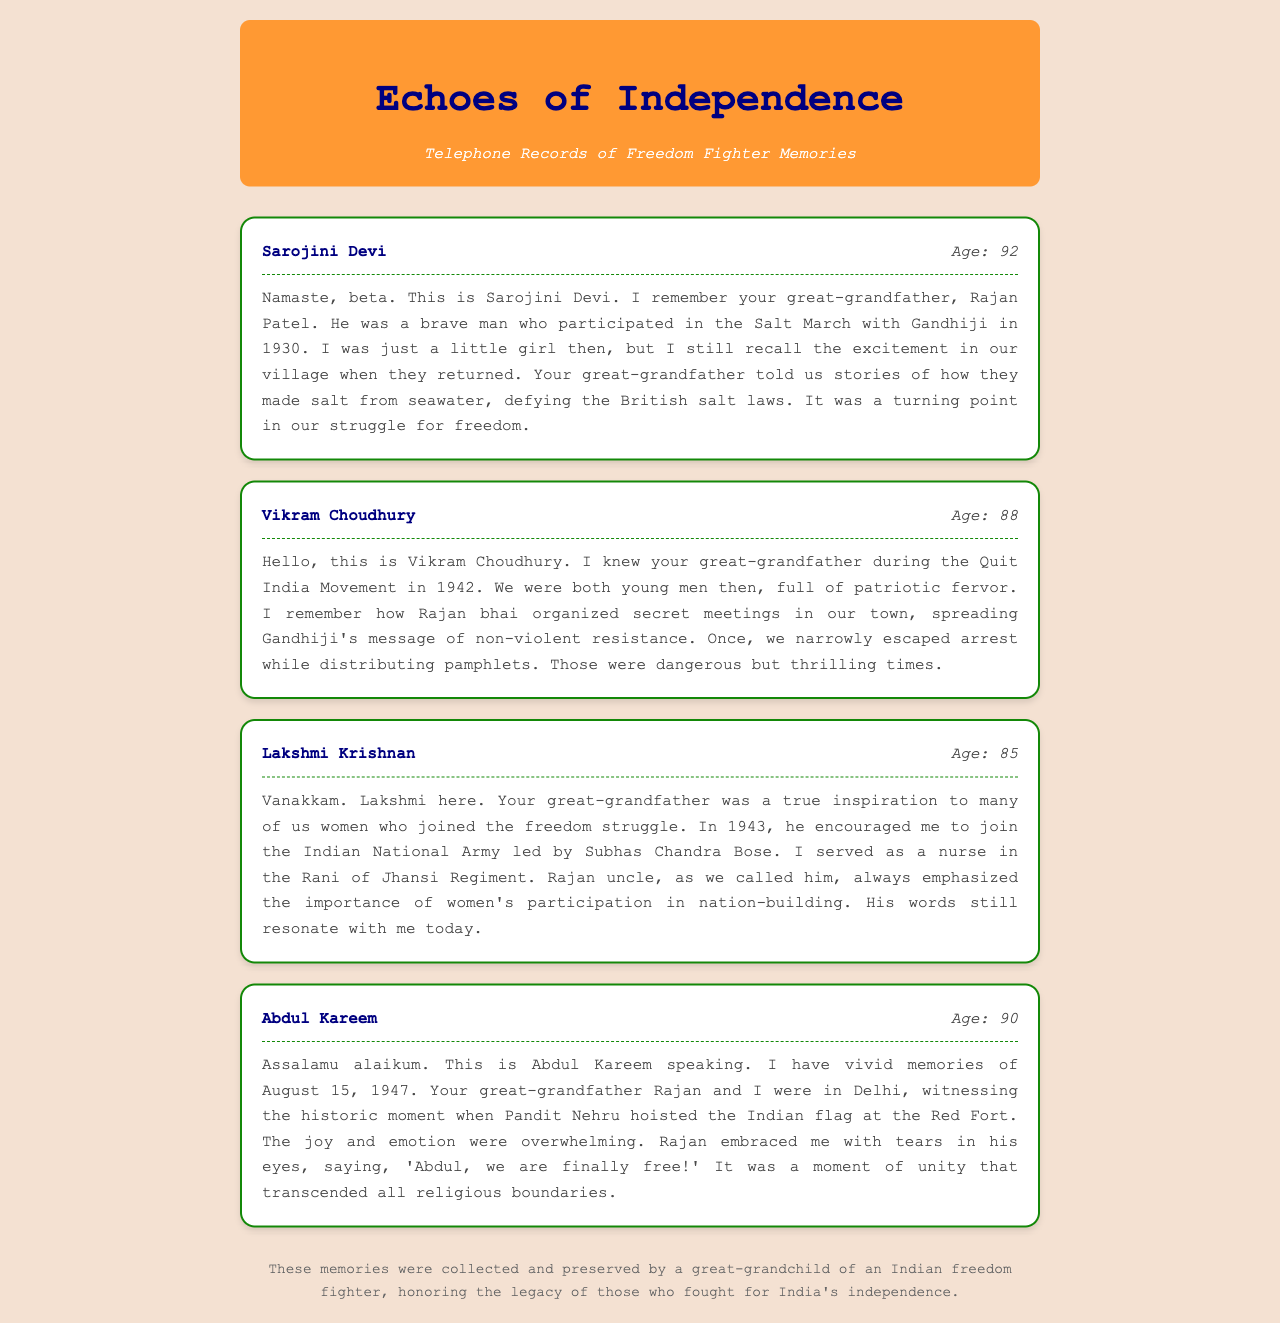What is the name of the first person sharing memories? The name of the first person is mentioned in the header of the record, which is Sarojini Devi.
Answer: Sarojini Devi How old is Vikram Choudhury? Vikram Choudhury's age is provided in the record header.
Answer: 88 In which year did Sarojini Devi recall the Salt March? The year of the Salt March is specified in Sarojini Devi's transcript as 1930.
Answer: 1930 Who organized secret meetings during the Quit India Movement? The transcript from Vikram Choudhury indicates that Rajan bhai organized secret meetings.
Answer: Rajan bhai What significant date is associated with Abdul Kareem's memory? Abdul Kareem recalls a significant historical date, which is August 15, 1947.
Answer: August 15, 1947 What did Rajan emphasized about women's participation? Lakshmi Krishnan mentions that Rajan emphasized the importance of women's participation in nation-building.
Answer: Importance of women's participation Which Indian leader’s name is mentioned in connection with Lakshmi Krishnan’s service? The transcript mentions Subhas Chandra Bose in relation to Lakshmi Krishnan's service.
Answer: Subhas Chandra Bose What event is described in Abdul Kareem's memory? Abdul Kareem describes the event of witnessing Pandit Nehru hoisting the Indian flag.
Answer: Hoisting the Indian flag What was Sarojini Devi's childhood experience related to? Sarojini Devi describes her childhood experience related to the excitement in their village.
Answer: Excitement in their village 